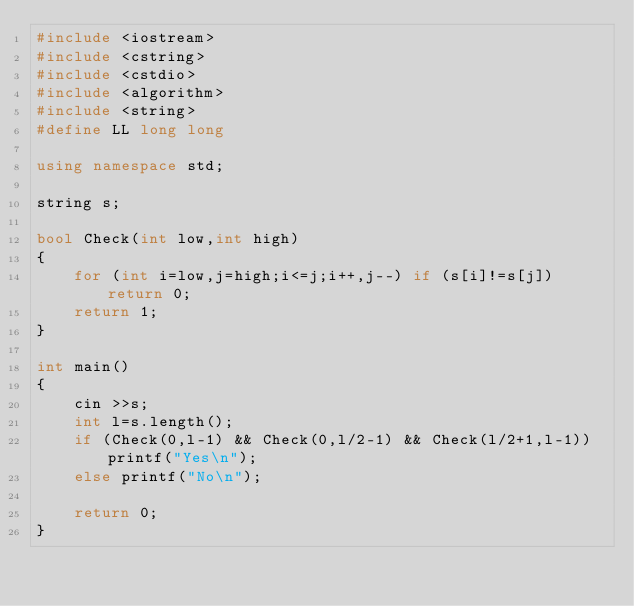<code> <loc_0><loc_0><loc_500><loc_500><_C++_>#include <iostream>
#include <cstring>
#include <cstdio>
#include <algorithm>
#include <string>
#define LL long long

using namespace std;

string s;

bool Check(int low,int high)
{
    for (int i=low,j=high;i<=j;i++,j--) if (s[i]!=s[j]) return 0;
    return 1;
}

int main()
{
    cin >>s;
    int l=s.length();
    if (Check(0,l-1) && Check(0,l/2-1) && Check(l/2+1,l-1)) printf("Yes\n");
    else printf("No\n");

    return 0;
}
</code> 